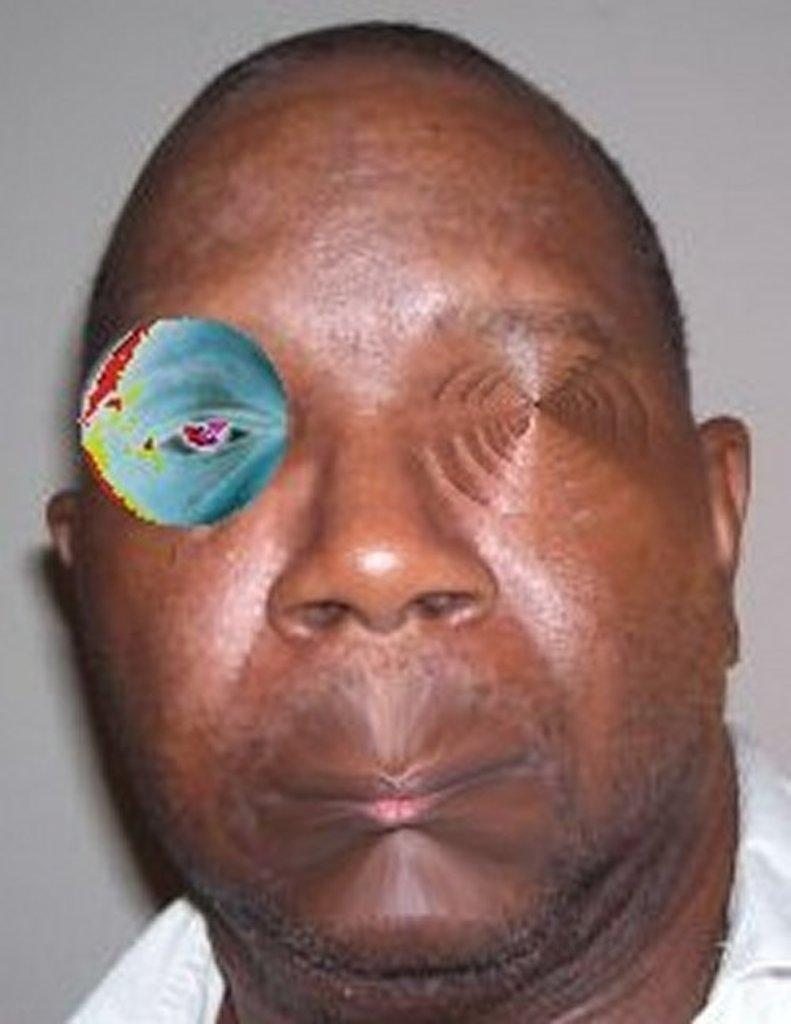What is the main subject of the image? There is a face of a person in the image. What is the stranger saying good-bye to in the image? There is no stranger or good-bye in the image; it only features the face of a person. 